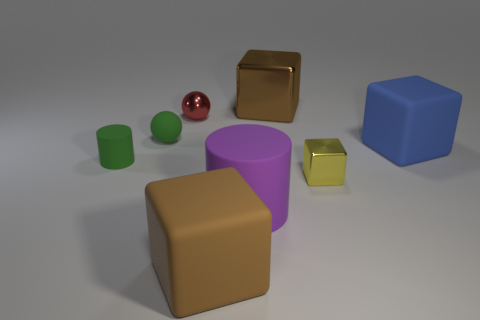There is a yellow metal thing that is the same size as the green cylinder; what is its shape?
Your answer should be very brief. Cube. How many tiny matte things are the same color as the large rubber cylinder?
Your answer should be compact. 0. What is the size of the metallic thing that is left of the big brown matte block?
Offer a terse response. Small. How many cubes have the same size as the brown metallic object?
Ensure brevity in your answer.  2. There is a sphere that is the same material as the purple cylinder; what color is it?
Provide a short and direct response. Green. Is the number of red metal things that are left of the rubber sphere less than the number of large blocks?
Your answer should be compact. Yes. The big brown object that is the same material as the yellow object is what shape?
Offer a very short reply. Cube. How many matte things are big cubes or tiny red things?
Provide a short and direct response. 2. Is the number of red objects left of the small matte cylinder the same as the number of big blue objects?
Offer a terse response. No. There is a metallic sphere that is behind the brown matte thing; does it have the same color as the small rubber cylinder?
Make the answer very short. No. 